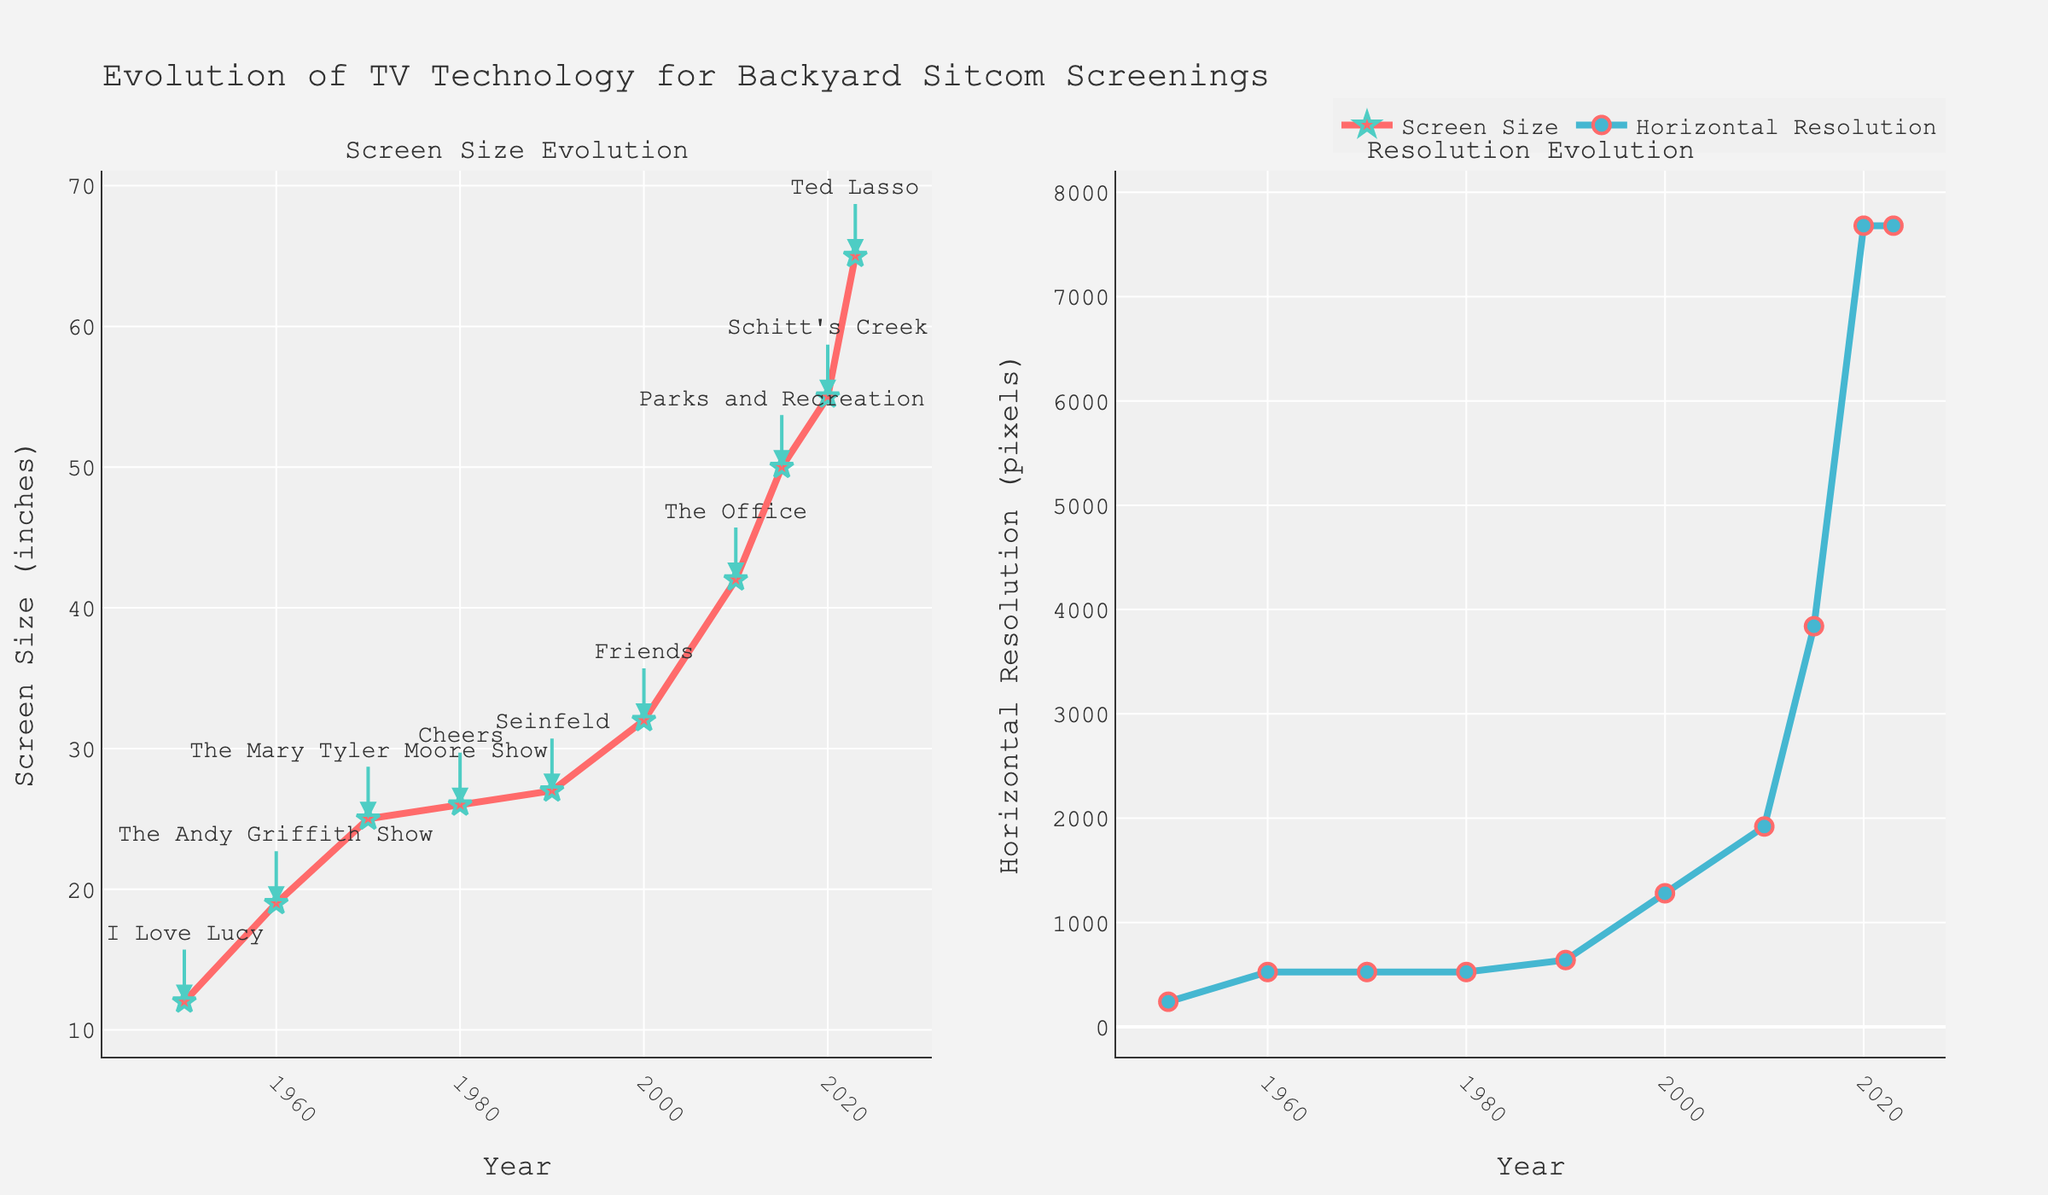What was the average screen size in 1970? Look at the "Screen Size Evolution" plot and find the data point for the year 1970. The average screen size for 1970 is marked as 25 inches.
Answer: 25 inches How much did the average resolution increase from 2000 to 2010? Check the "Resolution Evolution" plot for the years 2000 and 2010. The horizontal resolution in 2000 is 1280 pixels, and in 2010 it is 1920 pixels. The increase is 1920 - 1280 = 640 pixels.
Answer: 640 pixels Which sitcom had the benefit of 4K resolution? Refer to the annotations in the "Screen Size Evolution" plot. The sitcom "Parks and Recreation" appears at the year 2015, when the resolution was 3840x2160 (4K).
Answer: Parks and Recreation What was the horizontal resolution in the year "Friends" aired? Look at the year when "Friends" is annotated on the "Screen Size Evolution" plot, which is 2000. The corresponding horizontal resolution in the "Resolution Evolution" plot for 2000 is 1280 pixels.
Answer: 1280 pixels Compare screen sizes in 1950 and 2023. How much bigger is the average screen in 2023? Find the screen sizes for 1950 and 2023 in the "Screen Size Evolution" plot. In 1950, it is 12 inches, and in 2023, it is 65 inches. Calculate the difference: 65 - 12 = 53 inches.
Answer: 53 inches Which year marked the introduction of HD experience in backyard screenings? Refer to the "Screen Size Evolution" plot annotations. "Friends" marking the start of HD experience came in 2000.
Answer: 2000 How has the average screen size changed from the 1980s to the 1990s? Identify the screen sizes for 1980 and 1990 in the "Screen Size Evolution" plot. In 1980, the screen size is 26 inches, and in 1990, it is 27 inches. The change is 27 - 26 = 1 inch.
Answer: Increased by 1 inch Which year showed the largest increase in horizontal resolution compared to the previous decade? Check the "Resolution Evolution" plot and calculate differences. From 2000 to 2010 (1280 to 1920 pixels), the increase is 640 pixels. From 2010 to 2015 (1920 to 3840 pixels), the increase is 1920 pixels. The largest increase is from 2010 to 2015.
Answer: 2015 How does the average screen resolution in the 1960s compare to that in the 1980s? Compare the horizontal resolutions shown in the "Resolution Evolution" plot for the 1960s (525 pixels) and 1980s (525 pixels). Both are the same.
Answer: No change In what year did 8K resolution become available, and which sitcom aired during that time? Look at the "Resolution Evolution" plot and find the 7680-pixel mark, which first appears in 2020. The corresponding sitcom annotated in 2020 is "Schitt's Creek".
Answer: 2020, Schitt's Creek 